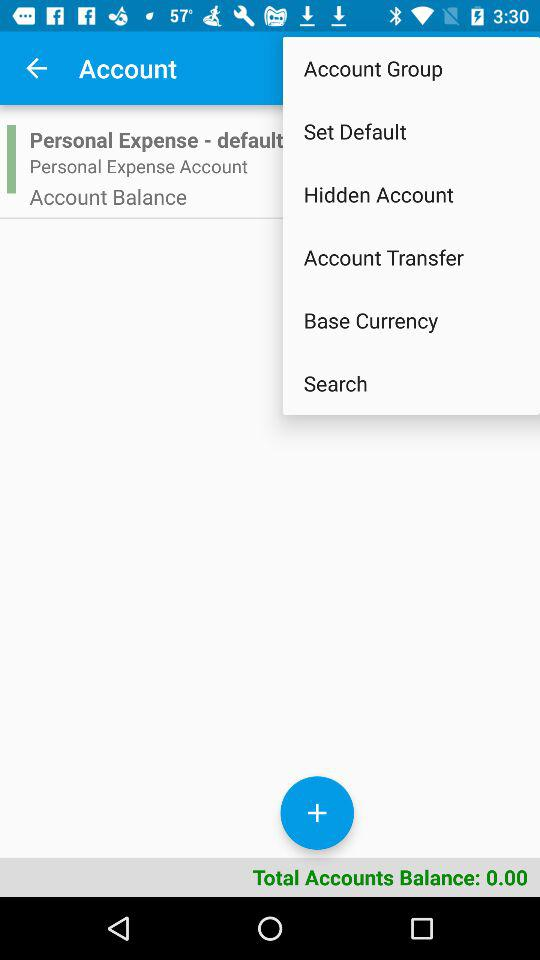What is the total available account balance? The total available account balance is 0.00. 